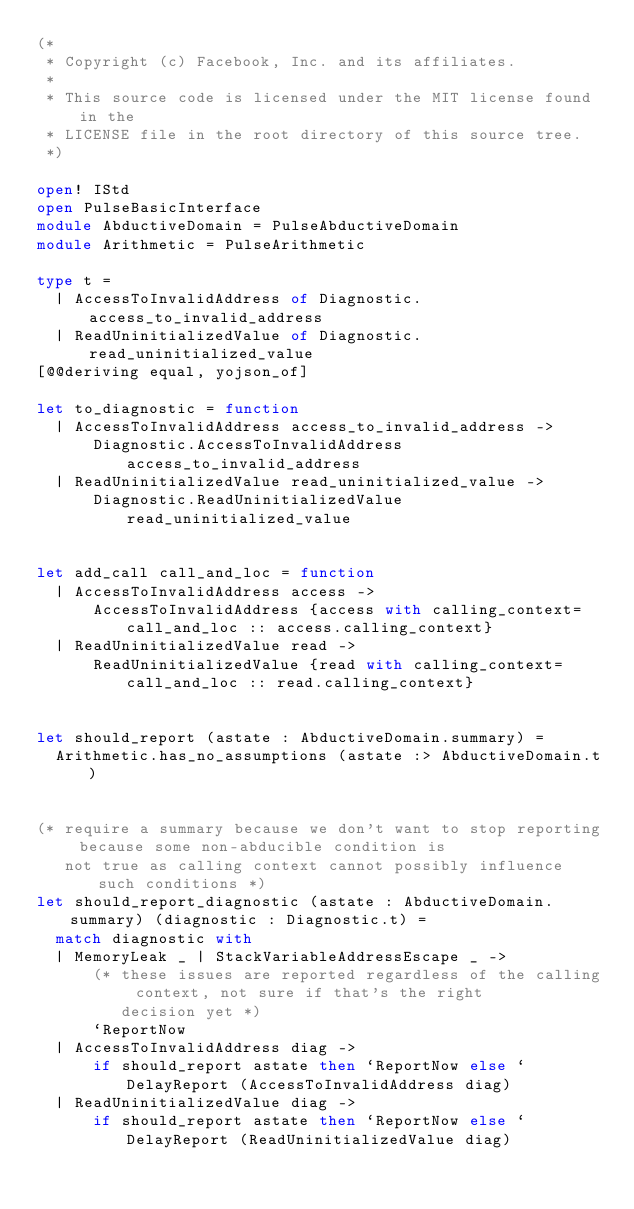<code> <loc_0><loc_0><loc_500><loc_500><_OCaml_>(*
 * Copyright (c) Facebook, Inc. and its affiliates.
 *
 * This source code is licensed under the MIT license found in the
 * LICENSE file in the root directory of this source tree.
 *)

open! IStd
open PulseBasicInterface
module AbductiveDomain = PulseAbductiveDomain
module Arithmetic = PulseArithmetic

type t =
  | AccessToInvalidAddress of Diagnostic.access_to_invalid_address
  | ReadUninitializedValue of Diagnostic.read_uninitialized_value
[@@deriving equal, yojson_of]

let to_diagnostic = function
  | AccessToInvalidAddress access_to_invalid_address ->
      Diagnostic.AccessToInvalidAddress access_to_invalid_address
  | ReadUninitializedValue read_uninitialized_value ->
      Diagnostic.ReadUninitializedValue read_uninitialized_value


let add_call call_and_loc = function
  | AccessToInvalidAddress access ->
      AccessToInvalidAddress {access with calling_context= call_and_loc :: access.calling_context}
  | ReadUninitializedValue read ->
      ReadUninitializedValue {read with calling_context= call_and_loc :: read.calling_context}


let should_report (astate : AbductiveDomain.summary) =
  Arithmetic.has_no_assumptions (astate :> AbductiveDomain.t)


(* require a summary because we don't want to stop reporting because some non-abducible condition is
   not true as calling context cannot possibly influence such conditions *)
let should_report_diagnostic (astate : AbductiveDomain.summary) (diagnostic : Diagnostic.t) =
  match diagnostic with
  | MemoryLeak _ | StackVariableAddressEscape _ ->
      (* these issues are reported regardless of the calling context, not sure if that's the right
         decision yet *)
      `ReportNow
  | AccessToInvalidAddress diag ->
      if should_report astate then `ReportNow else `DelayReport (AccessToInvalidAddress diag)
  | ReadUninitializedValue diag ->
      if should_report astate then `ReportNow else `DelayReport (ReadUninitializedValue diag)
</code> 